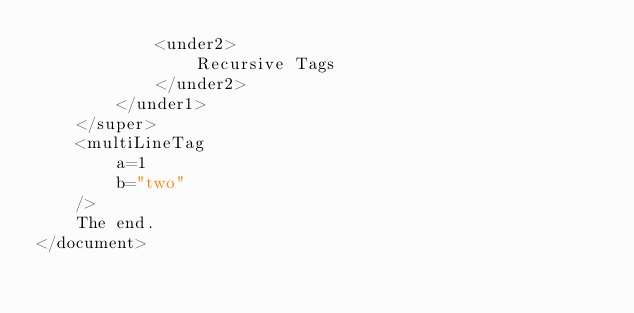<code> <loc_0><loc_0><loc_500><loc_500><_XML_>			<under2>
				Recursive Tags
			</under2>
		</under1>
	</super>
	<multiLineTag
		a=1
		b="two"
	/>
	The end.
</document>
</code> 